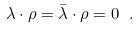<formula> <loc_0><loc_0><loc_500><loc_500>\lambda \cdot \rho = \bar { \lambda } \cdot \rho = 0 \ .</formula> 